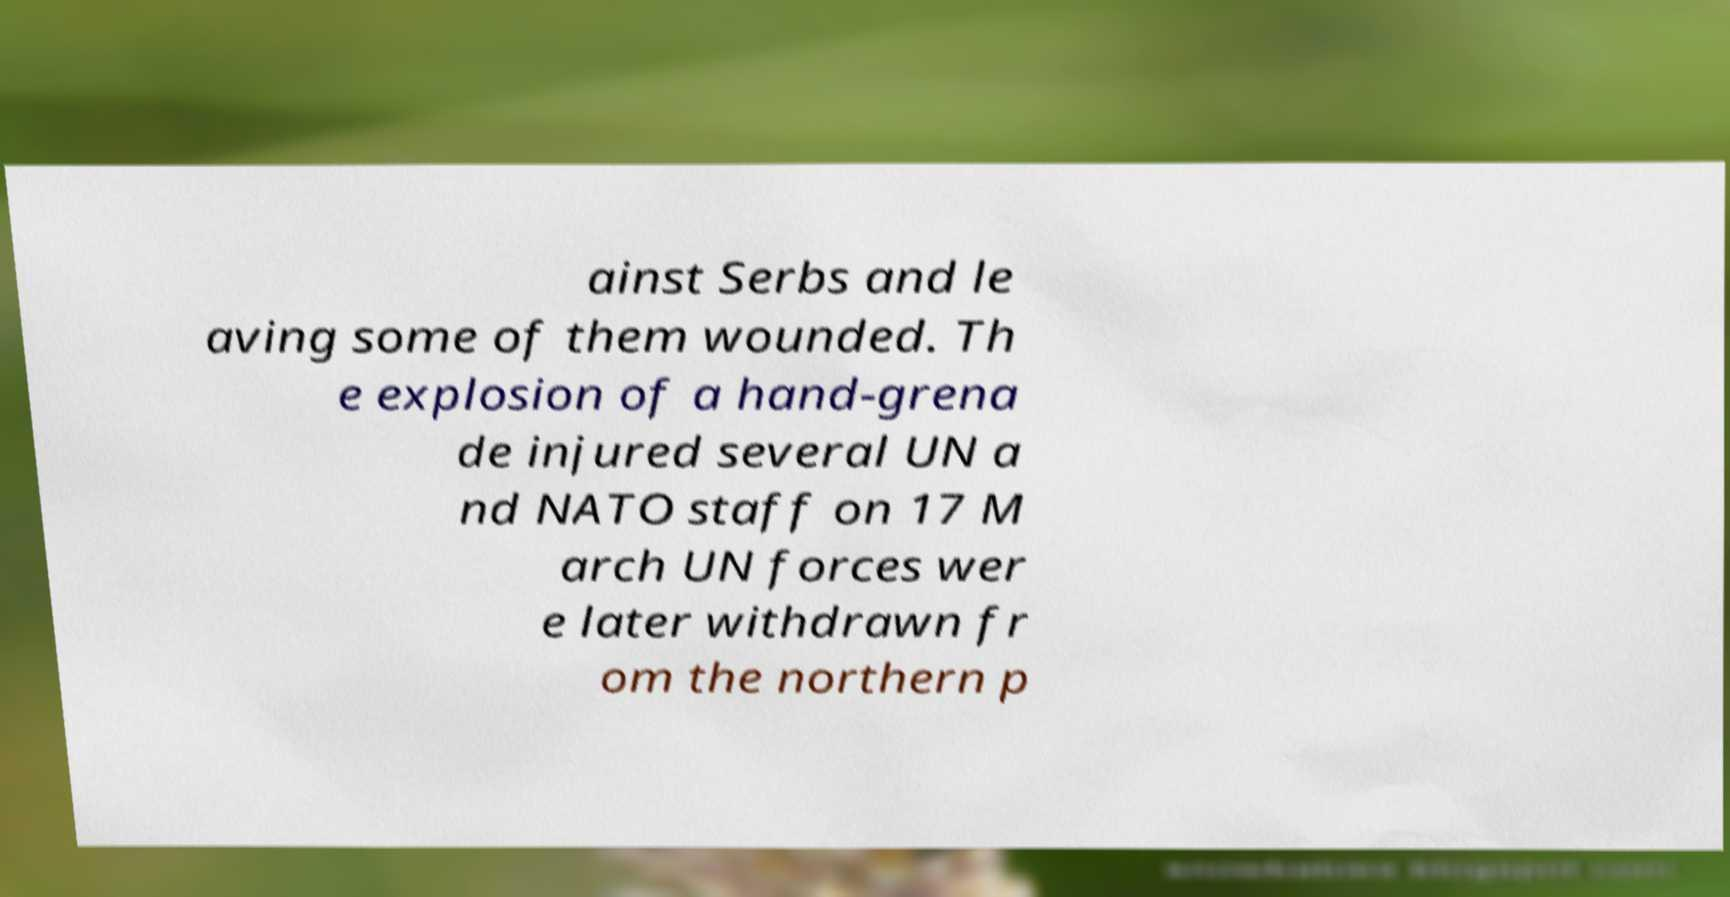I need the written content from this picture converted into text. Can you do that? ainst Serbs and le aving some of them wounded. Th e explosion of a hand-grena de injured several UN a nd NATO staff on 17 M arch UN forces wer e later withdrawn fr om the northern p 